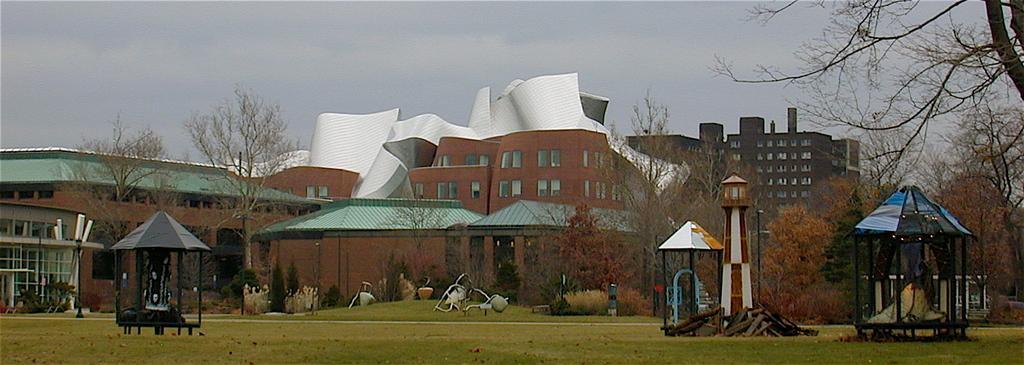Please provide a concise description of this image. In this image I can see an open grass ground in the front and on it I can see number of things. In the background I can see number of plants, number of trees, few buildings, clouds and the sky. 